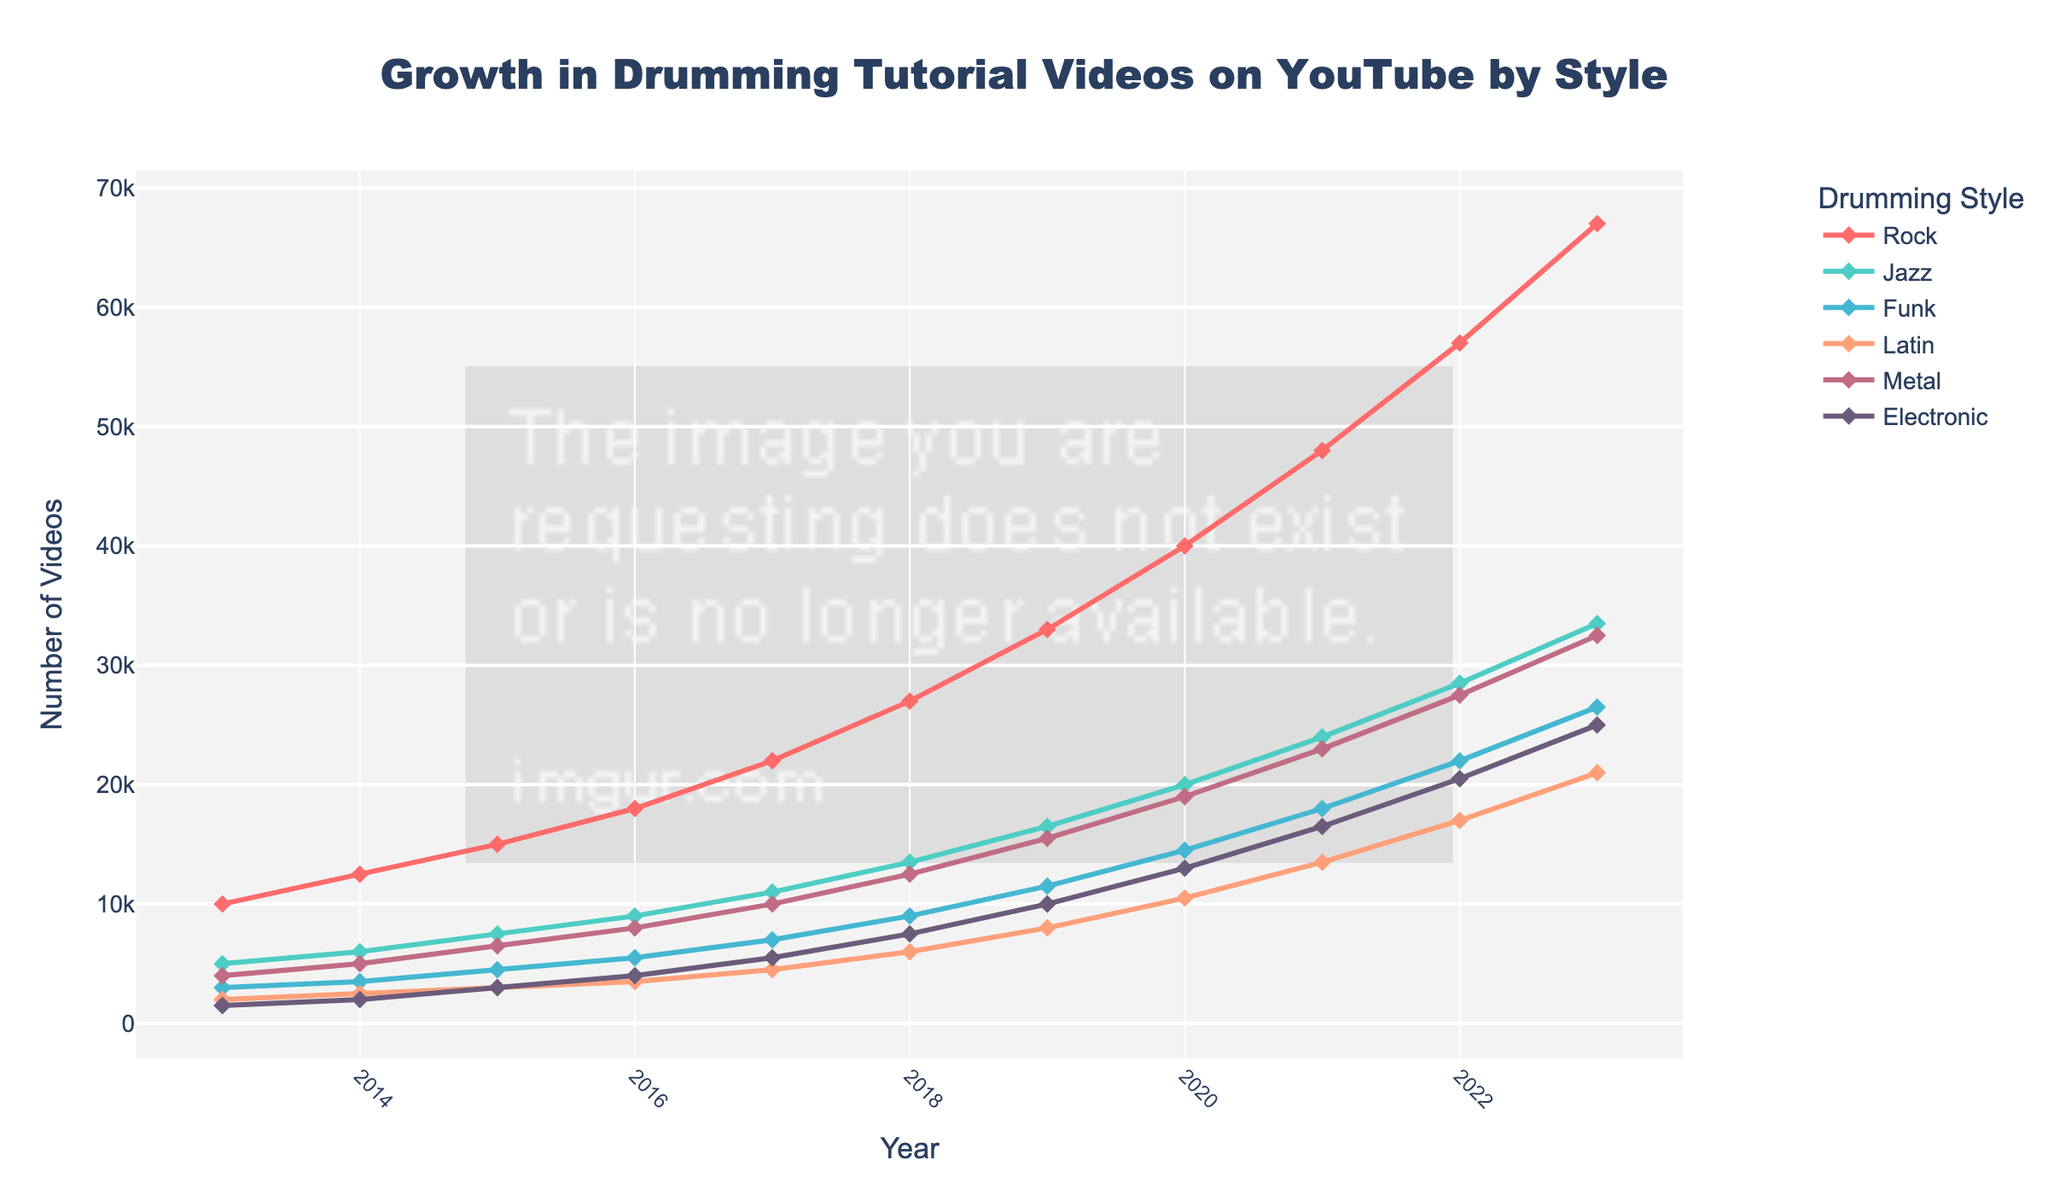Which drumming style saw the highest growth in the number of tutorial videos over the last decade? To determine which style had the highest growth, we need to compare the increase in the number of tutorial videos from 2013 to 2023 for each style. Rock increased by 57,000 - 10,000 = 47,000 videos; Jazz by 33,500 - 5,000 = 28,500; Funk by 26,500 - 3,000 = 23,500; Latin by 21,000 - 2,000 = 19,000; Metal by 32,500 - 4,000 = 28,500; Electronic by 25,000 - 1,500 = 23,500. The Rock style saw the highest growth.
Answer: Rock In which year did Metal drumming tutorials first surpass 20,000 videos? We look at the Metal data in the figure to see when it first exceeded 20,000 videos. In 2021, the number of Metal drumming tutorials was 23,000, and it was below 20,000 in 2020.
Answer: 2021 What is the average number of Electronic drumming tutorial videos posted annually over the last decade? To find the average, add the number of Electronic tutorials for each year from 2013 to 2023, then divide by 11. (1,500 + 2,000 + 3,000 + 4,000 + 5,500 + 7,500 + 10,000 + 13,000 + 16,500 + 20,500 + 25,000) / 11 = 88,500 / 11 = 8,045
Answer: 8,045 Which drumming style showed the most consistent annual growth over the period? By observing the steady increase in the number of tutorial videos each year, the Jazz style displays the most consistent growth with a yearly increase that doesn’t fluctuate much from the average.
Answer: Jazz By how many videos did the number of Funk drumming tutorials increase between 2016 and 2020? Subtract the number of Funk tutorials in 2016 from the number in 2020. Funk tutorials in 2020: 14,500; in 2016: 5,500. The increase is 14,500 - 5,500 = 9,000 videos.
Answer: 9,000 If we consider the trend from 2023, which style might surpass Jazz in the number of tutorials within two years? To predict, compare the growth trends. Jazz had 33,500 videos in 2023. Both Rock and Metal are increasing. Rock is already above, and Metal's rapid growth trend suggests it may surpass Jazz soon. Metal, with its trend line, seems likely to surpass Jazz.
Answer: Metal Which year did all styles collectively have over 100,000 tutorials for the first time? Sum the number of tutorials of all styles for each year and see the first occurrence of a total over 100,000. In 2017, Rock (22,000) + Jazz (11,000) + Funk (7,000) + Latin (4,500) + Metal (10,000) + Electronic (5,500) = 60,000. In 2018, Rock (27,000) + Jazz (13,500) + Funk (9,000) + Latin (6,000) + Metal (12,500) + Electronic (7,500) = 75,500. In 2019, Rock (33,000) + Jazz (16,500) + Funk (11,500) + Latin (8,000) + Metal (15,500) + Electronic (10,000) = 94,500. In 2020: Rock (40,000) + Jazz (20,000) + Funk (14,500) + Latin (10,500) + Metal (19,000) + Electronic (13,000) = 117,000. Thus, it happened in 2020.
Answer: 2020 Which three drumming styles have the closest number of tutorial videos in 2023? Compare the number of videos for each style in 2023 to find the three closest in number: Rock (67,000), Jazz (33,500), Funk (26,500), Latin (21,000), Metal (32,500), Electronic (25,000). Jazz, Metal and Funk have the closest numbers.
Answer: Jazz, Metal, and Funk 